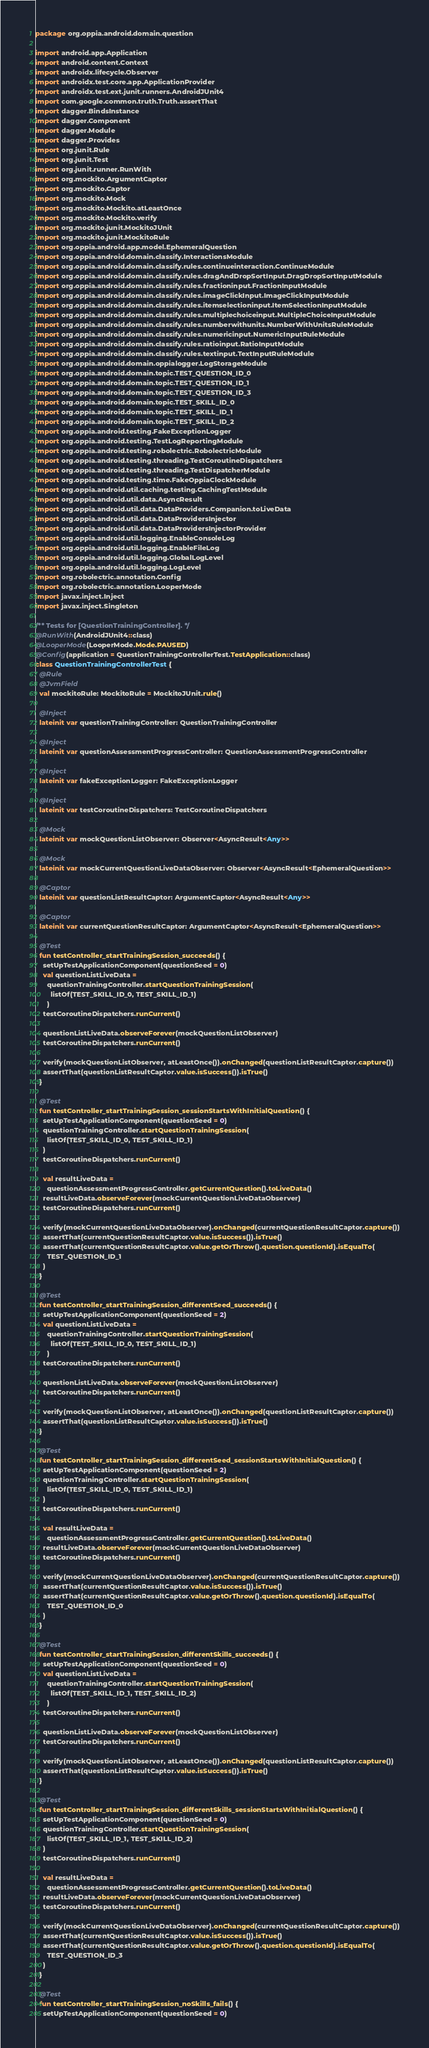Convert code to text. <code><loc_0><loc_0><loc_500><loc_500><_Kotlin_>package org.oppia.android.domain.question

import android.app.Application
import android.content.Context
import androidx.lifecycle.Observer
import androidx.test.core.app.ApplicationProvider
import androidx.test.ext.junit.runners.AndroidJUnit4
import com.google.common.truth.Truth.assertThat
import dagger.BindsInstance
import dagger.Component
import dagger.Module
import dagger.Provides
import org.junit.Rule
import org.junit.Test
import org.junit.runner.RunWith
import org.mockito.ArgumentCaptor
import org.mockito.Captor
import org.mockito.Mock
import org.mockito.Mockito.atLeastOnce
import org.mockito.Mockito.verify
import org.mockito.junit.MockitoJUnit
import org.mockito.junit.MockitoRule
import org.oppia.android.app.model.EphemeralQuestion
import org.oppia.android.domain.classify.InteractionsModule
import org.oppia.android.domain.classify.rules.continueinteraction.ContinueModule
import org.oppia.android.domain.classify.rules.dragAndDropSortInput.DragDropSortInputModule
import org.oppia.android.domain.classify.rules.fractioninput.FractionInputModule
import org.oppia.android.domain.classify.rules.imageClickInput.ImageClickInputModule
import org.oppia.android.domain.classify.rules.itemselectioninput.ItemSelectionInputModule
import org.oppia.android.domain.classify.rules.multiplechoiceinput.MultipleChoiceInputModule
import org.oppia.android.domain.classify.rules.numberwithunits.NumberWithUnitsRuleModule
import org.oppia.android.domain.classify.rules.numericinput.NumericInputRuleModule
import org.oppia.android.domain.classify.rules.ratioinput.RatioInputModule
import org.oppia.android.domain.classify.rules.textinput.TextInputRuleModule
import org.oppia.android.domain.oppialogger.LogStorageModule
import org.oppia.android.domain.topic.TEST_QUESTION_ID_0
import org.oppia.android.domain.topic.TEST_QUESTION_ID_1
import org.oppia.android.domain.topic.TEST_QUESTION_ID_3
import org.oppia.android.domain.topic.TEST_SKILL_ID_0
import org.oppia.android.domain.topic.TEST_SKILL_ID_1
import org.oppia.android.domain.topic.TEST_SKILL_ID_2
import org.oppia.android.testing.FakeExceptionLogger
import org.oppia.android.testing.TestLogReportingModule
import org.oppia.android.testing.robolectric.RobolectricModule
import org.oppia.android.testing.threading.TestCoroutineDispatchers
import org.oppia.android.testing.threading.TestDispatcherModule
import org.oppia.android.testing.time.FakeOppiaClockModule
import org.oppia.android.util.caching.testing.CachingTestModule
import org.oppia.android.util.data.AsyncResult
import org.oppia.android.util.data.DataProviders.Companion.toLiveData
import org.oppia.android.util.data.DataProvidersInjector
import org.oppia.android.util.data.DataProvidersInjectorProvider
import org.oppia.android.util.logging.EnableConsoleLog
import org.oppia.android.util.logging.EnableFileLog
import org.oppia.android.util.logging.GlobalLogLevel
import org.oppia.android.util.logging.LogLevel
import org.robolectric.annotation.Config
import org.robolectric.annotation.LooperMode
import javax.inject.Inject
import javax.inject.Singleton

/** Tests for [QuestionTrainingController]. */
@RunWith(AndroidJUnit4::class)
@LooperMode(LooperMode.Mode.PAUSED)
@Config(application = QuestionTrainingControllerTest.TestApplication::class)
class QuestionTrainingControllerTest {
  @Rule
  @JvmField
  val mockitoRule: MockitoRule = MockitoJUnit.rule()

  @Inject
  lateinit var questionTrainingController: QuestionTrainingController

  @Inject
  lateinit var questionAssessmentProgressController: QuestionAssessmentProgressController

  @Inject
  lateinit var fakeExceptionLogger: FakeExceptionLogger

  @Inject
  lateinit var testCoroutineDispatchers: TestCoroutineDispatchers

  @Mock
  lateinit var mockQuestionListObserver: Observer<AsyncResult<Any>>

  @Mock
  lateinit var mockCurrentQuestionLiveDataObserver: Observer<AsyncResult<EphemeralQuestion>>

  @Captor
  lateinit var questionListResultCaptor: ArgumentCaptor<AsyncResult<Any>>

  @Captor
  lateinit var currentQuestionResultCaptor: ArgumentCaptor<AsyncResult<EphemeralQuestion>>

  @Test
  fun testController_startTrainingSession_succeeds() {
    setUpTestApplicationComponent(questionSeed = 0)
    val questionListLiveData =
      questionTrainingController.startQuestionTrainingSession(
        listOf(TEST_SKILL_ID_0, TEST_SKILL_ID_1)
      )
    testCoroutineDispatchers.runCurrent()

    questionListLiveData.observeForever(mockQuestionListObserver)
    testCoroutineDispatchers.runCurrent()

    verify(mockQuestionListObserver, atLeastOnce()).onChanged(questionListResultCaptor.capture())
    assertThat(questionListResultCaptor.value.isSuccess()).isTrue()
  }

  @Test
  fun testController_startTrainingSession_sessionStartsWithInitialQuestion() {
    setUpTestApplicationComponent(questionSeed = 0)
    questionTrainingController.startQuestionTrainingSession(
      listOf(TEST_SKILL_ID_0, TEST_SKILL_ID_1)
    )
    testCoroutineDispatchers.runCurrent()

    val resultLiveData =
      questionAssessmentProgressController.getCurrentQuestion().toLiveData()
    resultLiveData.observeForever(mockCurrentQuestionLiveDataObserver)
    testCoroutineDispatchers.runCurrent()

    verify(mockCurrentQuestionLiveDataObserver).onChanged(currentQuestionResultCaptor.capture())
    assertThat(currentQuestionResultCaptor.value.isSuccess()).isTrue()
    assertThat(currentQuestionResultCaptor.value.getOrThrow().question.questionId).isEqualTo(
      TEST_QUESTION_ID_1
    )
  }

  @Test
  fun testController_startTrainingSession_differentSeed_succeeds() {
    setUpTestApplicationComponent(questionSeed = 2)
    val questionListLiveData =
      questionTrainingController.startQuestionTrainingSession(
        listOf(TEST_SKILL_ID_0, TEST_SKILL_ID_1)
      )
    testCoroutineDispatchers.runCurrent()

    questionListLiveData.observeForever(mockQuestionListObserver)
    testCoroutineDispatchers.runCurrent()

    verify(mockQuestionListObserver, atLeastOnce()).onChanged(questionListResultCaptor.capture())
    assertThat(questionListResultCaptor.value.isSuccess()).isTrue()
  }

  @Test
  fun testController_startTrainingSession_differentSeed_sessionStartsWithInitialQuestion() {
    setUpTestApplicationComponent(questionSeed = 2)
    questionTrainingController.startQuestionTrainingSession(
      listOf(TEST_SKILL_ID_0, TEST_SKILL_ID_1)
    )
    testCoroutineDispatchers.runCurrent()

    val resultLiveData =
      questionAssessmentProgressController.getCurrentQuestion().toLiveData()
    resultLiveData.observeForever(mockCurrentQuestionLiveDataObserver)
    testCoroutineDispatchers.runCurrent()

    verify(mockCurrentQuestionLiveDataObserver).onChanged(currentQuestionResultCaptor.capture())
    assertThat(currentQuestionResultCaptor.value.isSuccess()).isTrue()
    assertThat(currentQuestionResultCaptor.value.getOrThrow().question.questionId).isEqualTo(
      TEST_QUESTION_ID_0
    )
  }

  @Test
  fun testController_startTrainingSession_differentSkills_succeeds() {
    setUpTestApplicationComponent(questionSeed = 0)
    val questionListLiveData =
      questionTrainingController.startQuestionTrainingSession(
        listOf(TEST_SKILL_ID_1, TEST_SKILL_ID_2)
      )
    testCoroutineDispatchers.runCurrent()

    questionListLiveData.observeForever(mockQuestionListObserver)
    testCoroutineDispatchers.runCurrent()

    verify(mockQuestionListObserver, atLeastOnce()).onChanged(questionListResultCaptor.capture())
    assertThat(questionListResultCaptor.value.isSuccess()).isTrue()
  }

  @Test
  fun testController_startTrainingSession_differentSkills_sessionStartsWithInitialQuestion() {
    setUpTestApplicationComponent(questionSeed = 0)
    questionTrainingController.startQuestionTrainingSession(
      listOf(TEST_SKILL_ID_1, TEST_SKILL_ID_2)
    )
    testCoroutineDispatchers.runCurrent()

    val resultLiveData =
      questionAssessmentProgressController.getCurrentQuestion().toLiveData()
    resultLiveData.observeForever(mockCurrentQuestionLiveDataObserver)
    testCoroutineDispatchers.runCurrent()

    verify(mockCurrentQuestionLiveDataObserver).onChanged(currentQuestionResultCaptor.capture())
    assertThat(currentQuestionResultCaptor.value.isSuccess()).isTrue()
    assertThat(currentQuestionResultCaptor.value.getOrThrow().question.questionId).isEqualTo(
      TEST_QUESTION_ID_3
    )
  }

  @Test
  fun testController_startTrainingSession_noSkills_fails() {
    setUpTestApplicationComponent(questionSeed = 0)</code> 